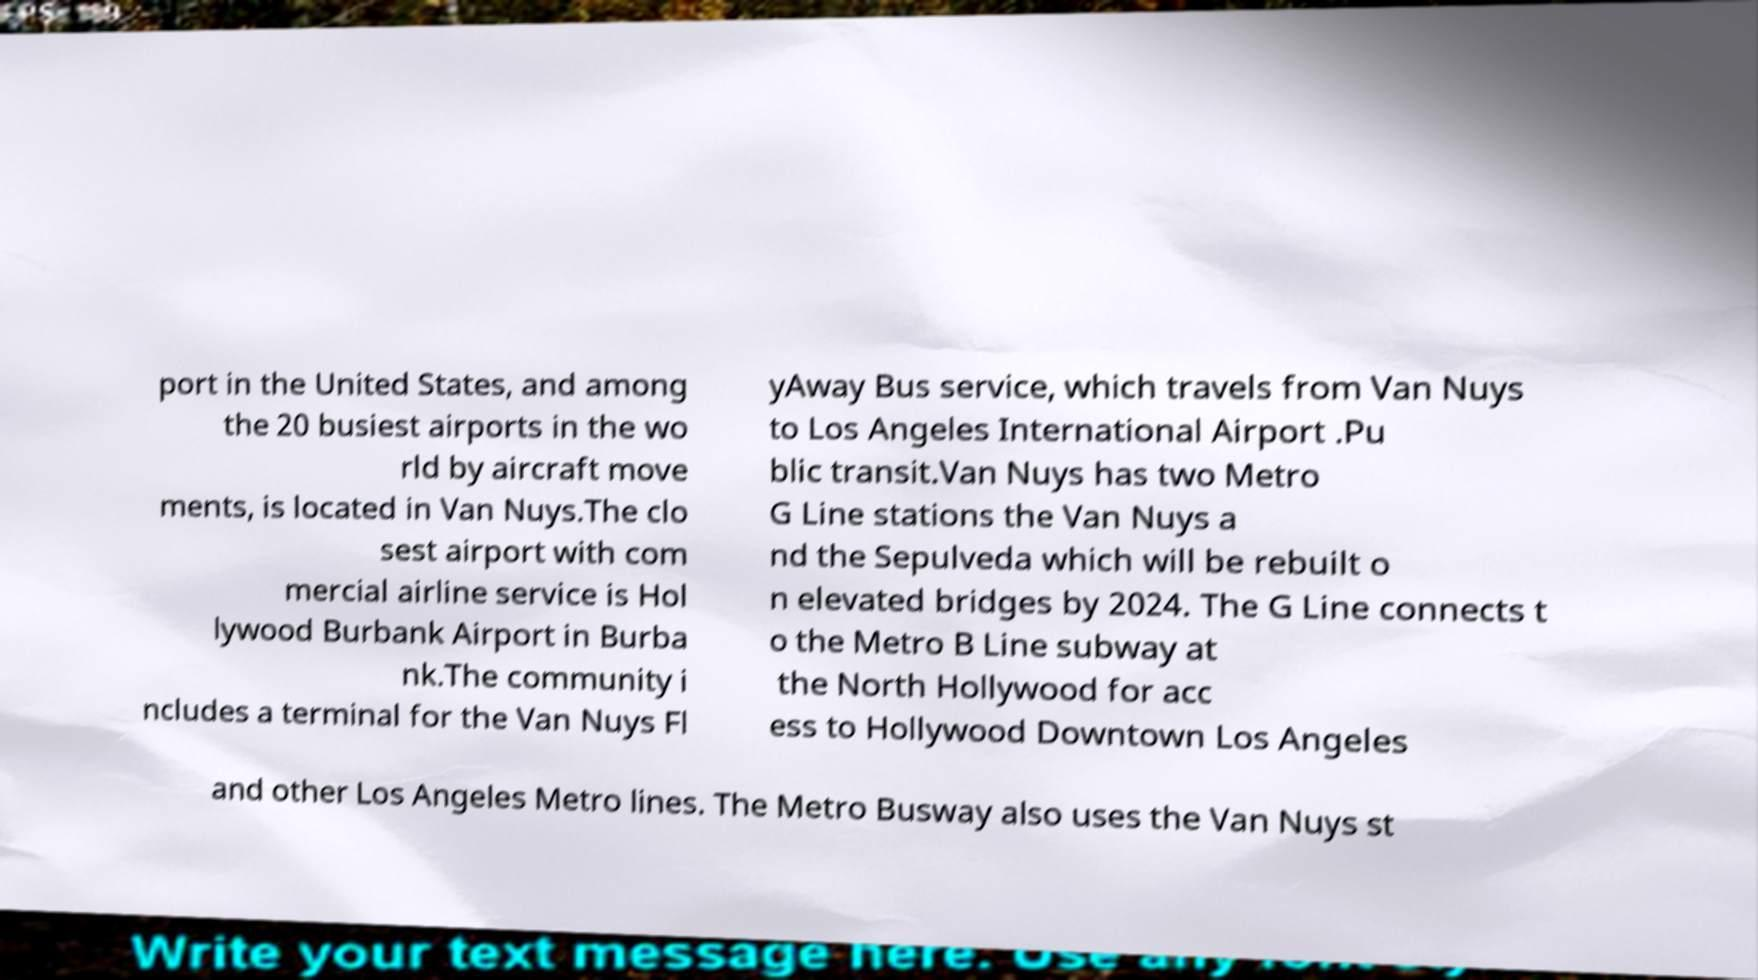Please identify and transcribe the text found in this image. port in the United States, and among the 20 busiest airports in the wo rld by aircraft move ments, is located in Van Nuys.The clo sest airport with com mercial airline service is Hol lywood Burbank Airport in Burba nk.The community i ncludes a terminal for the Van Nuys Fl yAway Bus service, which travels from Van Nuys to Los Angeles International Airport .Pu blic transit.Van Nuys has two Metro G Line stations the Van Nuys a nd the Sepulveda which will be rebuilt o n elevated bridges by 2024. The G Line connects t o the Metro B Line subway at the North Hollywood for acc ess to Hollywood Downtown Los Angeles and other Los Angeles Metro lines. The Metro Busway also uses the Van Nuys st 